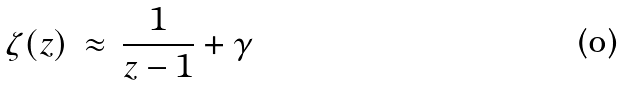Convert formula to latex. <formula><loc_0><loc_0><loc_500><loc_500>\zeta ( z ) \, \approx \, \frac { 1 } { z - 1 } + \gamma</formula> 